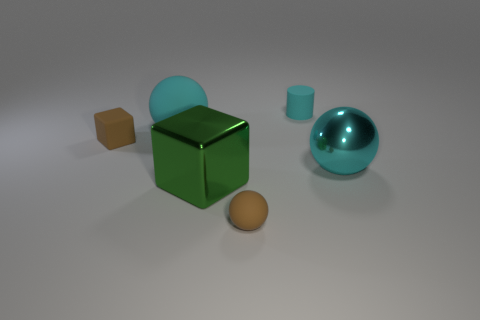How big is the sphere on the left side of the small ball?
Give a very brief answer. Large. What is the block that is behind the big sphere that is in front of the tiny brown rubber block made of?
Provide a short and direct response. Rubber. There is a block in front of the cyan sphere that is right of the matte cylinder; what number of large cyan rubber things are to the right of it?
Make the answer very short. 0. Are the big cyan ball that is in front of the brown block and the brown object behind the big cyan metallic sphere made of the same material?
Provide a short and direct response. No. There is a tiny sphere that is the same color as the rubber cube; what is it made of?
Ensure brevity in your answer.  Rubber. How many other rubber objects are the same shape as the green object?
Make the answer very short. 1. Are there more things in front of the small brown ball than brown matte things?
Provide a succinct answer. No. What is the shape of the cyan object in front of the rubber ball behind the metallic thing that is to the right of the small cyan thing?
Make the answer very short. Sphere. There is a metallic thing that is behind the large green metal object; is it the same shape as the brown matte object to the left of the large rubber sphere?
Provide a short and direct response. No. Are there any other things that have the same size as the brown block?
Make the answer very short. Yes. 